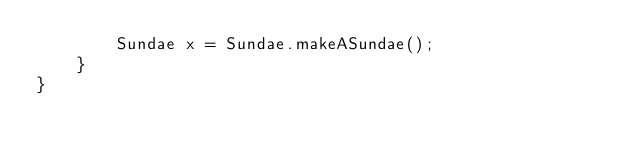<code> <loc_0><loc_0><loc_500><loc_500><_Java_>        Sundae x = Sundae.makeASundae();
    }
}
</code> 